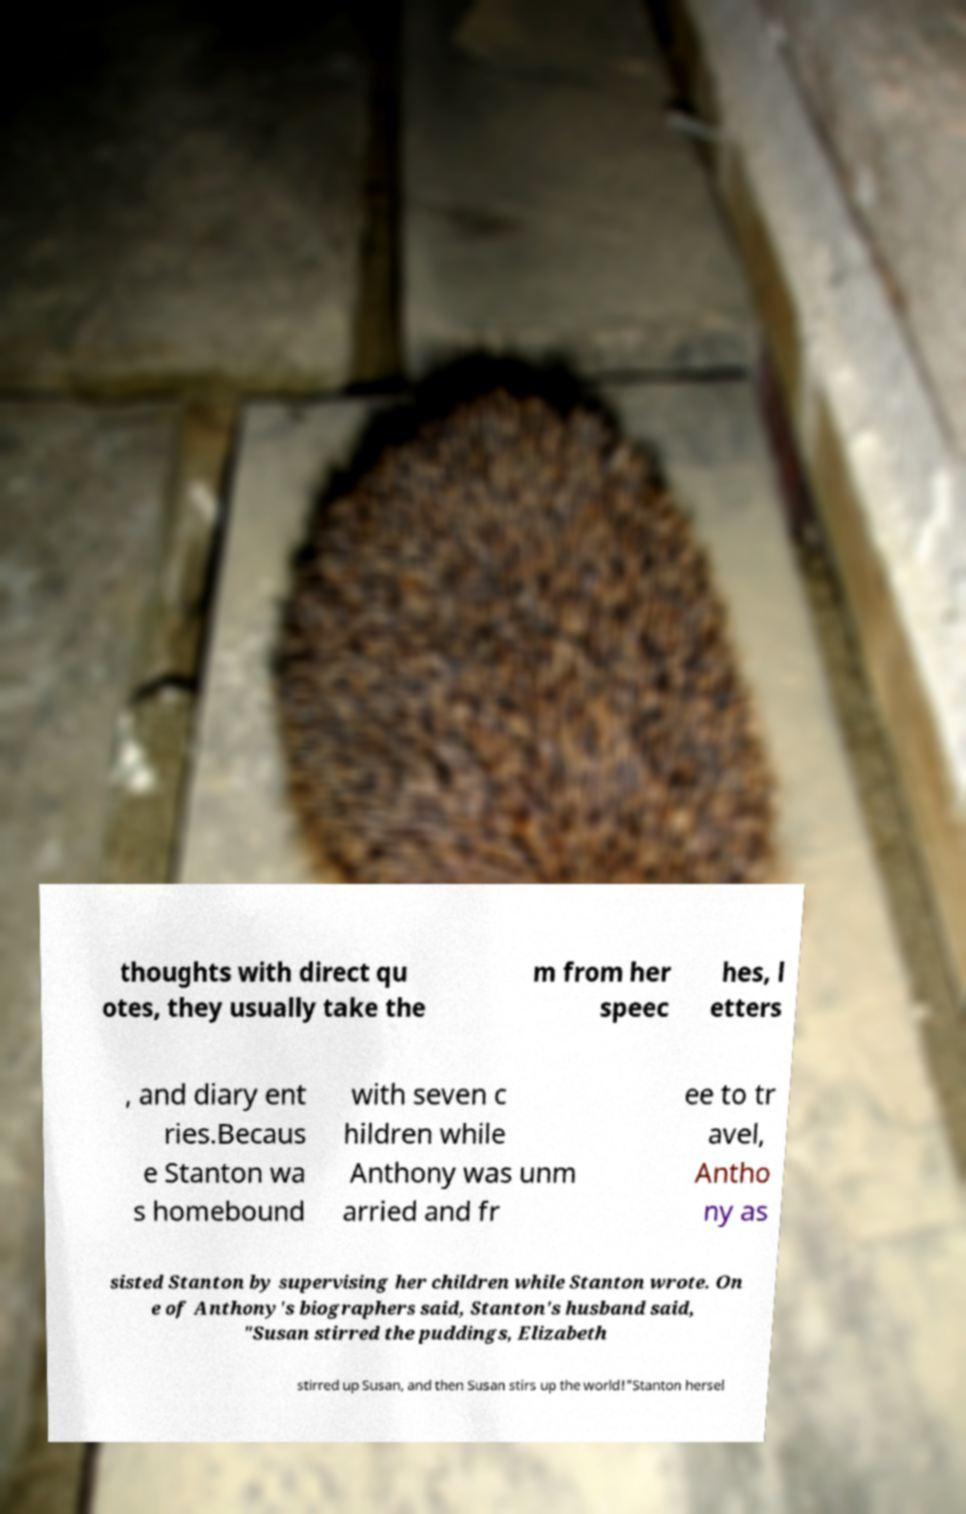There's text embedded in this image that I need extracted. Can you transcribe it verbatim? thoughts with direct qu otes, they usually take the m from her speec hes, l etters , and diary ent ries.Becaus e Stanton wa s homebound with seven c hildren while Anthony was unm arried and fr ee to tr avel, Antho ny as sisted Stanton by supervising her children while Stanton wrote. On e of Anthony's biographers said, Stanton's husband said, "Susan stirred the puddings, Elizabeth stirred up Susan, and then Susan stirs up the world!"Stanton hersel 